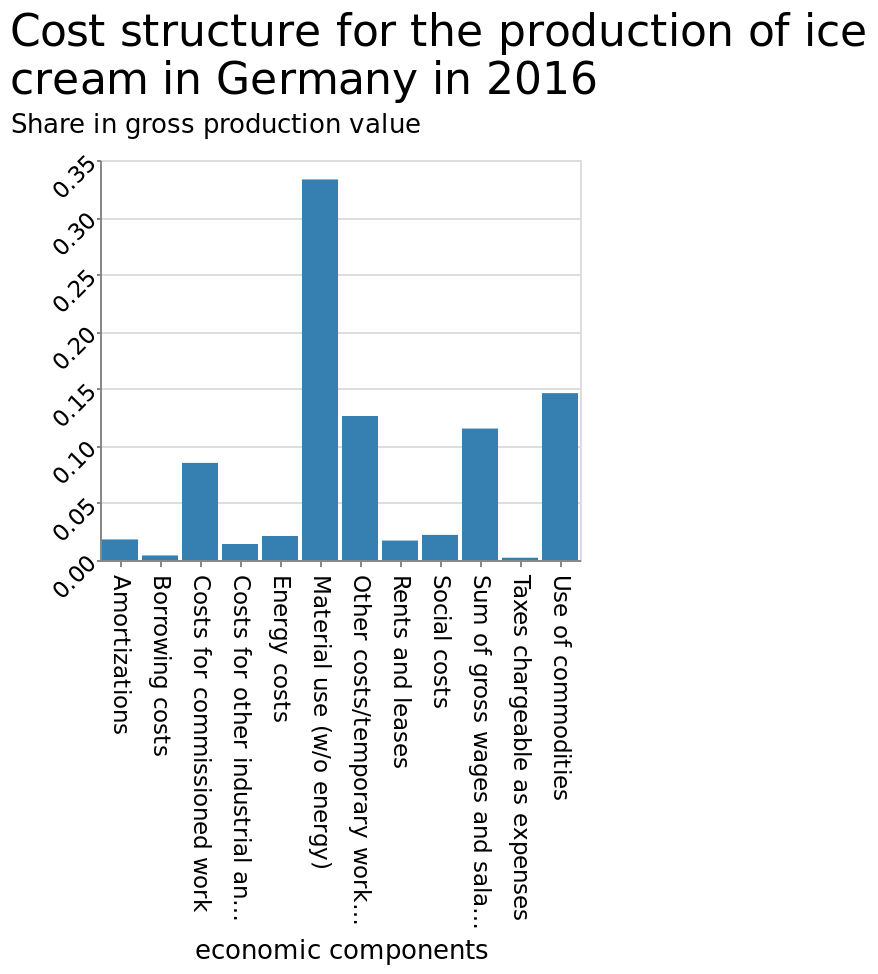<image>
What is the value of gross production in Material use sector? The value of gross production in Material use sector is not provided in the description. What does the bar plot show? The bar plot shows the cost structure for the production of ice cream in Germany in 2016. Which sector has the highest gross production value? Material use sector has the highest gross production value. In which country was the production of ice cream analyzed? The production of ice cream was analyzed in Germany. Does the scatter plot show the revenue structure for the production of ice cream in Germany in 2016? No.The bar plot shows the cost structure for the production of ice cream in Germany in 2016. 